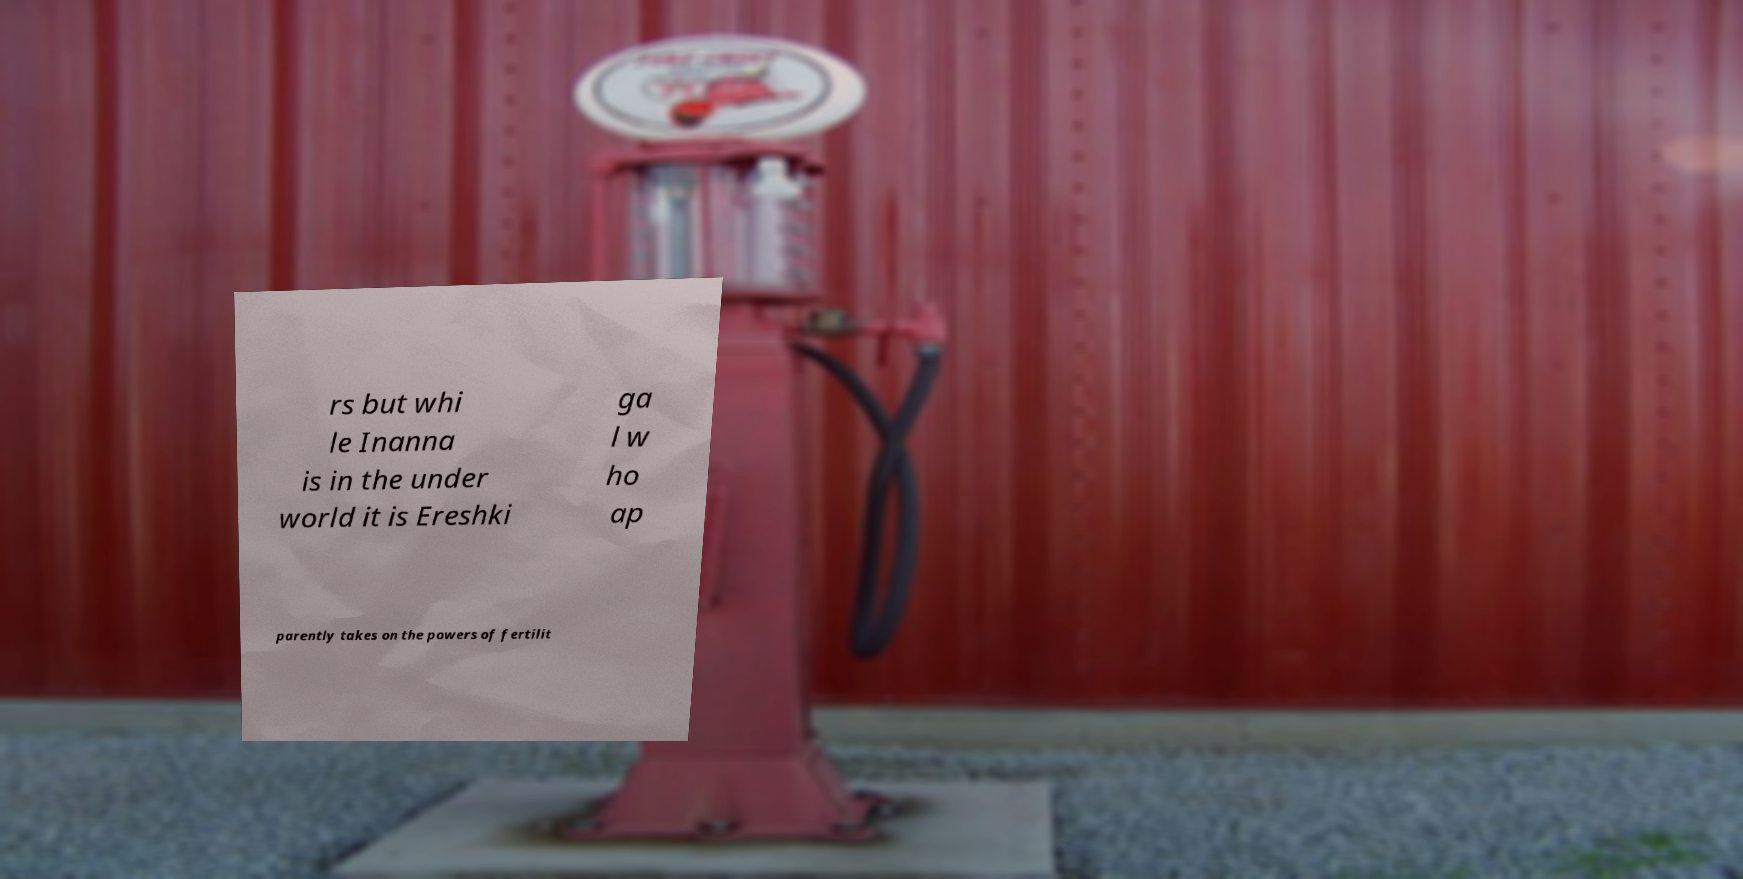Can you read and provide the text displayed in the image?This photo seems to have some interesting text. Can you extract and type it out for me? rs but whi le Inanna is in the under world it is Ereshki ga l w ho ap parently takes on the powers of fertilit 